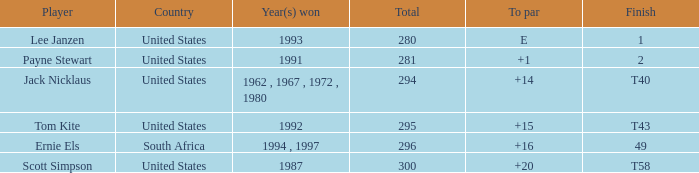What is the Total of the Player with a Finish of 1? 1.0. 